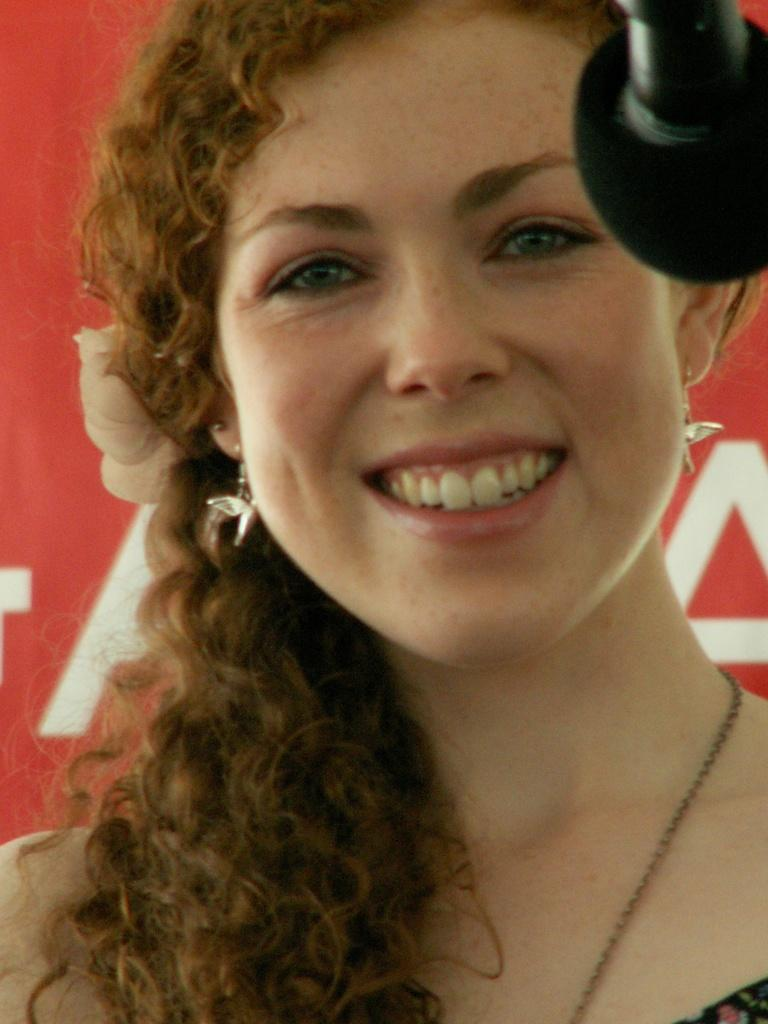Who is present in the image? There is a woman in the image. What is the woman wearing? The woman is wearing clothes, a neck chain, and earrings. What is the woman's facial expression? The woman is smiling. What objects can be seen in the image besides the woman? There is a microphone and a poster in the image. What type of pies is the woman holding in the image? There are no pies present in the image. Who is the woman's partner in the image? There is no partner mentioned or depicted in the image. 